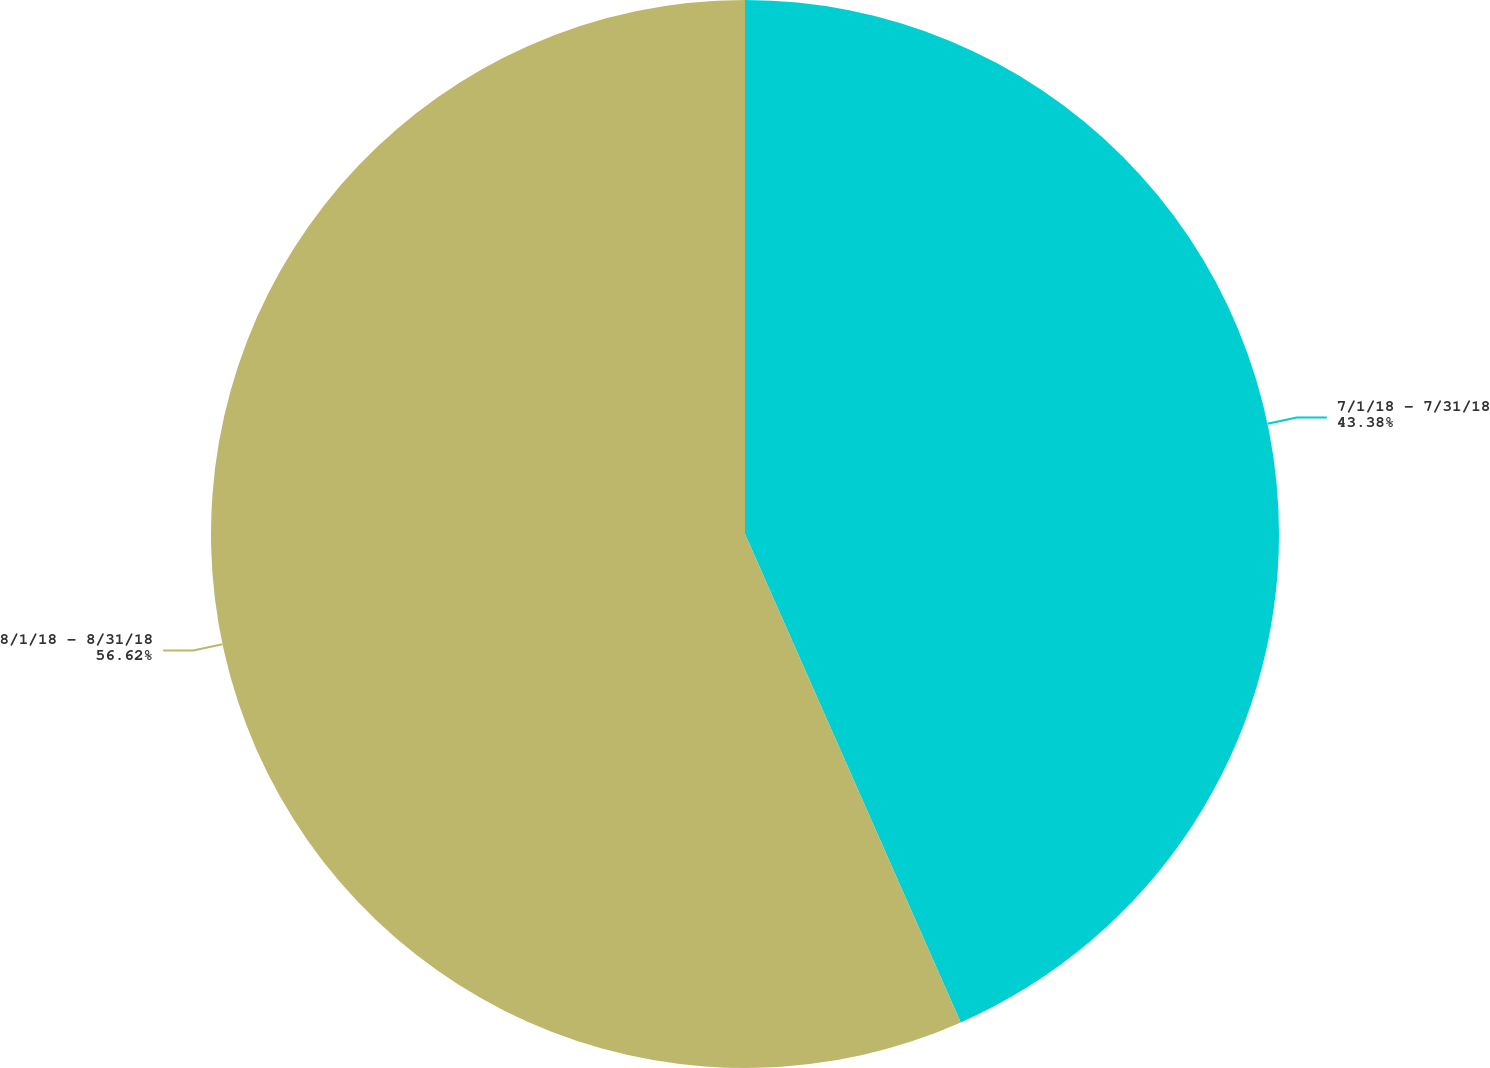Convert chart to OTSL. <chart><loc_0><loc_0><loc_500><loc_500><pie_chart><fcel>7/1/18 - 7/31/18<fcel>8/1/18 - 8/31/18<nl><fcel>43.38%<fcel>56.62%<nl></chart> 